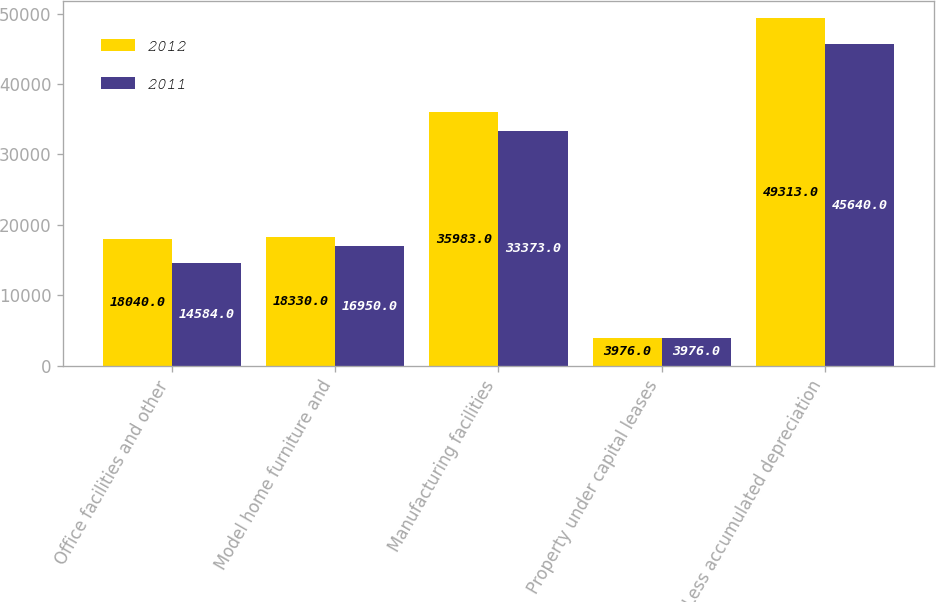Convert chart to OTSL. <chart><loc_0><loc_0><loc_500><loc_500><stacked_bar_chart><ecel><fcel>Office facilities and other<fcel>Model home furniture and<fcel>Manufacturing facilities<fcel>Property under capital leases<fcel>Less accumulated depreciation<nl><fcel>2012<fcel>18040<fcel>18330<fcel>35983<fcel>3976<fcel>49313<nl><fcel>2011<fcel>14584<fcel>16950<fcel>33373<fcel>3976<fcel>45640<nl></chart> 